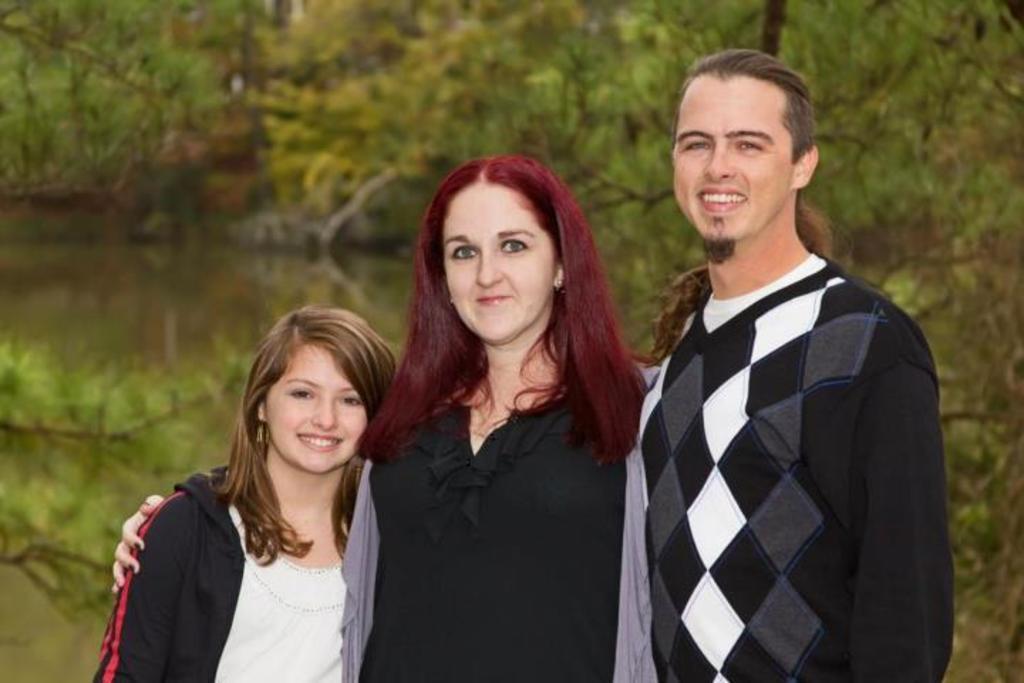Describe this image in one or two sentences. There are three persons standing and smiling. In the background there are trees. 